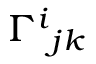Convert formula to latex. <formula><loc_0><loc_0><loc_500><loc_500>\Gamma ^ { i _ { j k }</formula> 